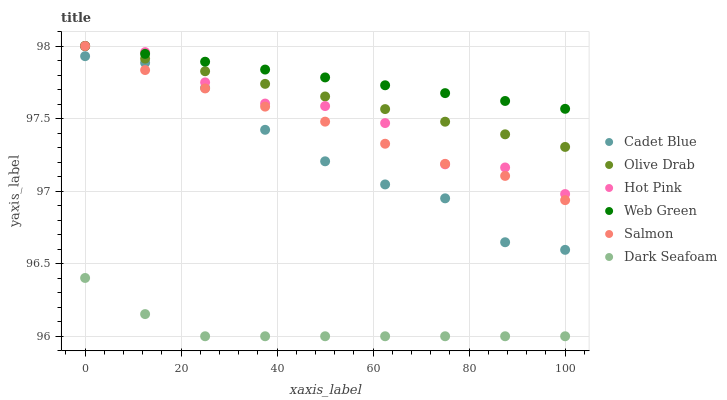Does Dark Seafoam have the minimum area under the curve?
Answer yes or no. Yes. Does Web Green have the maximum area under the curve?
Answer yes or no. Yes. Does Hot Pink have the minimum area under the curve?
Answer yes or no. No. Does Hot Pink have the maximum area under the curve?
Answer yes or no. No. Is Web Green the smoothest?
Answer yes or no. Yes. Is Hot Pink the roughest?
Answer yes or no. Yes. Is Salmon the smoothest?
Answer yes or no. No. Is Salmon the roughest?
Answer yes or no. No. Does Dark Seafoam have the lowest value?
Answer yes or no. Yes. Does Hot Pink have the lowest value?
Answer yes or no. No. Does Olive Drab have the highest value?
Answer yes or no. Yes. Does Dark Seafoam have the highest value?
Answer yes or no. No. Is Cadet Blue less than Olive Drab?
Answer yes or no. Yes. Is Hot Pink greater than Cadet Blue?
Answer yes or no. Yes. Does Hot Pink intersect Salmon?
Answer yes or no. Yes. Is Hot Pink less than Salmon?
Answer yes or no. No. Is Hot Pink greater than Salmon?
Answer yes or no. No. Does Cadet Blue intersect Olive Drab?
Answer yes or no. No. 